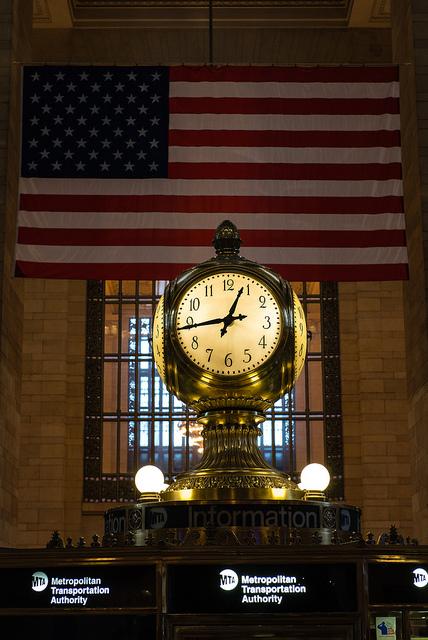Is there a flag in this picture?
Write a very short answer. Yes. How many stripes are on the flag?
Write a very short answer. 13. How many light sources are in this picture?
Keep it brief. 3. 